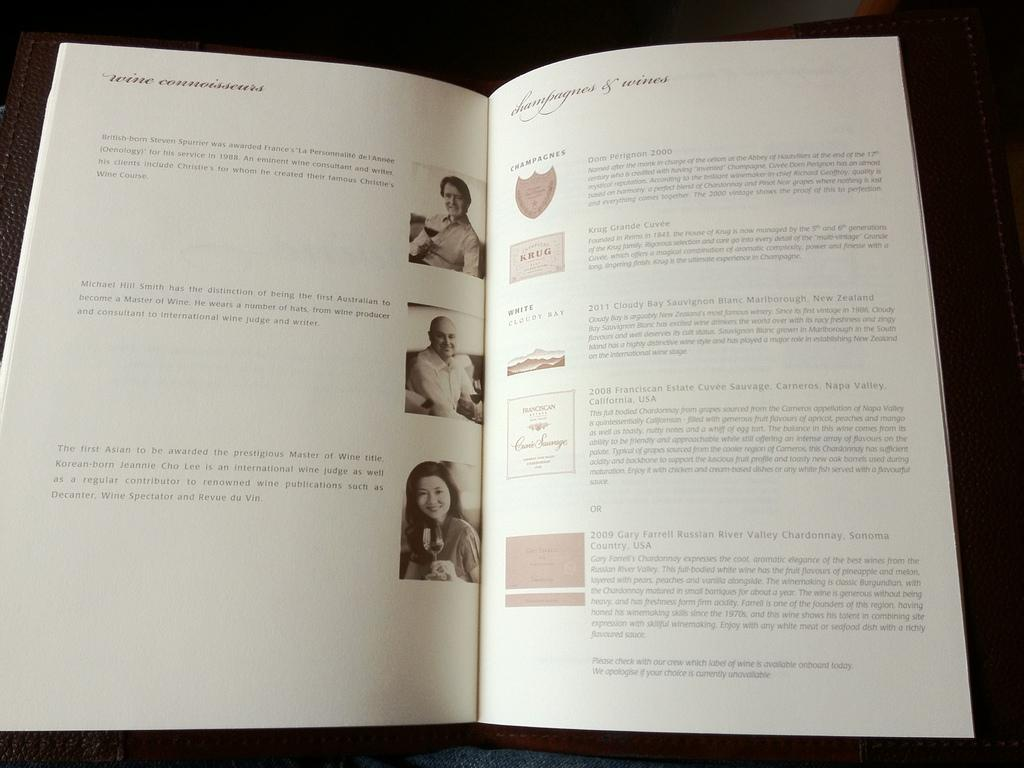<image>
Create a compact narrative representing the image presented. A wine book with opinions from different wine connoisseurs 